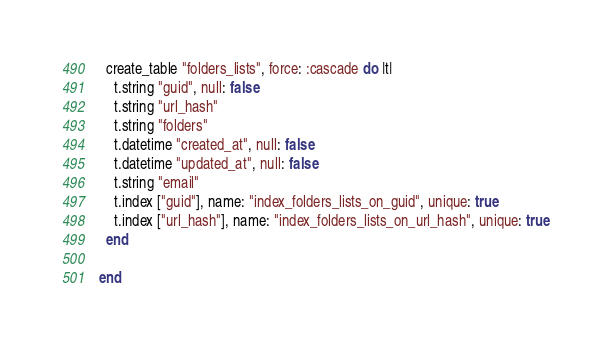<code> <loc_0><loc_0><loc_500><loc_500><_Ruby_>  create_table "folders_lists", force: :cascade do |t|
    t.string "guid", null: false
    t.string "url_hash"
    t.string "folders"
    t.datetime "created_at", null: false
    t.datetime "updated_at", null: false
    t.string "email"
    t.index ["guid"], name: "index_folders_lists_on_guid", unique: true
    t.index ["url_hash"], name: "index_folders_lists_on_url_hash", unique: true
  end

end
</code> 